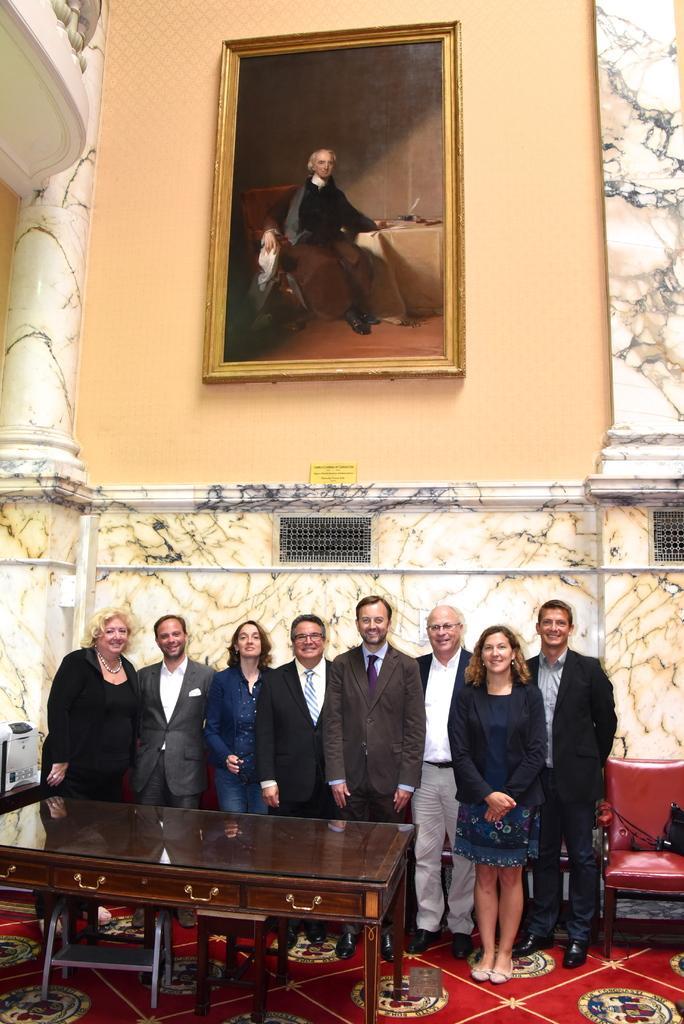In one or two sentences, can you explain what this image depicts? A picture on wall. These persons are standing and giving stills. In-front of them there is a table. We can able to see a red chair. 